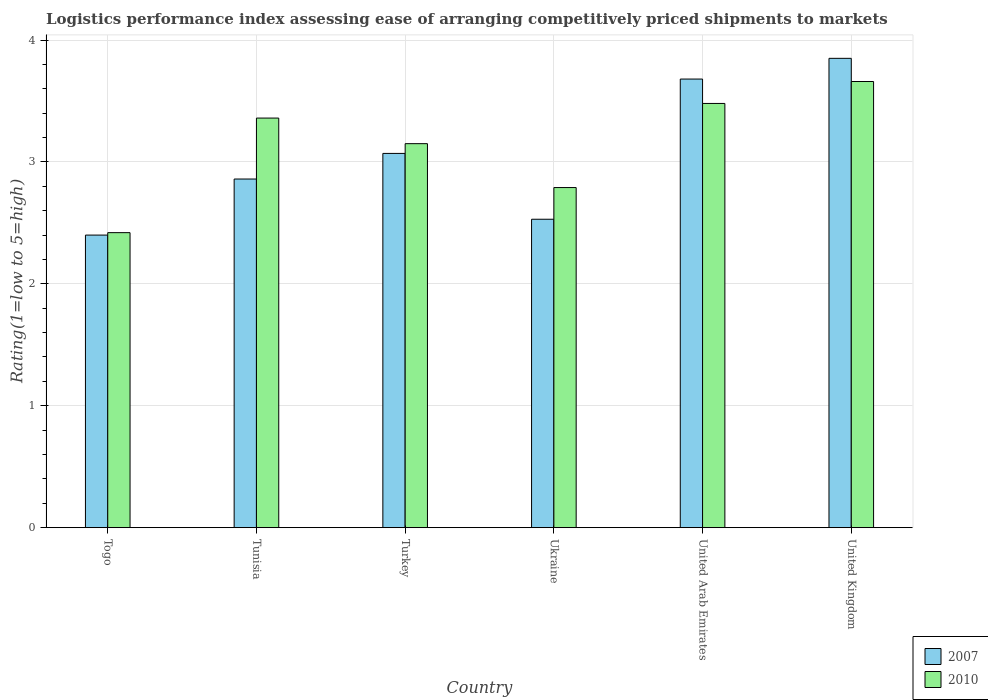How many groups of bars are there?
Offer a very short reply. 6. Are the number of bars on each tick of the X-axis equal?
Make the answer very short. Yes. How many bars are there on the 3rd tick from the left?
Offer a terse response. 2. How many bars are there on the 3rd tick from the right?
Your answer should be very brief. 2. What is the label of the 5th group of bars from the left?
Make the answer very short. United Arab Emirates. In how many cases, is the number of bars for a given country not equal to the number of legend labels?
Offer a terse response. 0. What is the Logistic performance index in 2010 in Tunisia?
Offer a very short reply. 3.36. Across all countries, what is the maximum Logistic performance index in 2007?
Offer a very short reply. 3.85. In which country was the Logistic performance index in 2010 minimum?
Keep it short and to the point. Togo. What is the total Logistic performance index in 2010 in the graph?
Provide a succinct answer. 18.86. What is the difference between the Logistic performance index in 2007 in Tunisia and that in Turkey?
Offer a very short reply. -0.21. What is the difference between the Logistic performance index in 2007 in United Kingdom and the Logistic performance index in 2010 in United Arab Emirates?
Offer a terse response. 0.37. What is the average Logistic performance index in 2010 per country?
Your response must be concise. 3.14. What is the difference between the Logistic performance index of/in 2007 and Logistic performance index of/in 2010 in Tunisia?
Ensure brevity in your answer.  -0.5. In how many countries, is the Logistic performance index in 2007 greater than 0.6000000000000001?
Your answer should be very brief. 6. What is the ratio of the Logistic performance index in 2010 in Turkey to that in United Kingdom?
Keep it short and to the point. 0.86. Is the difference between the Logistic performance index in 2007 in Togo and Tunisia greater than the difference between the Logistic performance index in 2010 in Togo and Tunisia?
Make the answer very short. Yes. What is the difference between the highest and the second highest Logistic performance index in 2007?
Your answer should be compact. -0.17. What is the difference between the highest and the lowest Logistic performance index in 2010?
Provide a short and direct response. 1.24. Is the sum of the Logistic performance index in 2010 in Tunisia and United Kingdom greater than the maximum Logistic performance index in 2007 across all countries?
Provide a short and direct response. Yes. What does the 1st bar from the left in Tunisia represents?
Give a very brief answer. 2007. What is the difference between two consecutive major ticks on the Y-axis?
Your response must be concise. 1. Are the values on the major ticks of Y-axis written in scientific E-notation?
Offer a very short reply. No. Does the graph contain grids?
Offer a terse response. Yes. Where does the legend appear in the graph?
Ensure brevity in your answer.  Bottom right. How many legend labels are there?
Make the answer very short. 2. What is the title of the graph?
Provide a succinct answer. Logistics performance index assessing ease of arranging competitively priced shipments to markets. Does "1994" appear as one of the legend labels in the graph?
Your answer should be very brief. No. What is the label or title of the X-axis?
Give a very brief answer. Country. What is the label or title of the Y-axis?
Give a very brief answer. Rating(1=low to 5=high). What is the Rating(1=low to 5=high) of 2007 in Togo?
Make the answer very short. 2.4. What is the Rating(1=low to 5=high) in 2010 in Togo?
Your response must be concise. 2.42. What is the Rating(1=low to 5=high) in 2007 in Tunisia?
Provide a short and direct response. 2.86. What is the Rating(1=low to 5=high) in 2010 in Tunisia?
Provide a short and direct response. 3.36. What is the Rating(1=low to 5=high) in 2007 in Turkey?
Provide a succinct answer. 3.07. What is the Rating(1=low to 5=high) in 2010 in Turkey?
Offer a very short reply. 3.15. What is the Rating(1=low to 5=high) of 2007 in Ukraine?
Your answer should be very brief. 2.53. What is the Rating(1=low to 5=high) of 2010 in Ukraine?
Keep it short and to the point. 2.79. What is the Rating(1=low to 5=high) in 2007 in United Arab Emirates?
Offer a terse response. 3.68. What is the Rating(1=low to 5=high) of 2010 in United Arab Emirates?
Provide a succinct answer. 3.48. What is the Rating(1=low to 5=high) of 2007 in United Kingdom?
Your answer should be compact. 3.85. What is the Rating(1=low to 5=high) in 2010 in United Kingdom?
Your response must be concise. 3.66. Across all countries, what is the maximum Rating(1=low to 5=high) of 2007?
Provide a short and direct response. 3.85. Across all countries, what is the maximum Rating(1=low to 5=high) in 2010?
Make the answer very short. 3.66. Across all countries, what is the minimum Rating(1=low to 5=high) of 2007?
Your answer should be compact. 2.4. Across all countries, what is the minimum Rating(1=low to 5=high) of 2010?
Make the answer very short. 2.42. What is the total Rating(1=low to 5=high) in 2007 in the graph?
Your response must be concise. 18.39. What is the total Rating(1=low to 5=high) in 2010 in the graph?
Provide a short and direct response. 18.86. What is the difference between the Rating(1=low to 5=high) of 2007 in Togo and that in Tunisia?
Give a very brief answer. -0.46. What is the difference between the Rating(1=low to 5=high) of 2010 in Togo and that in Tunisia?
Give a very brief answer. -0.94. What is the difference between the Rating(1=low to 5=high) of 2007 in Togo and that in Turkey?
Make the answer very short. -0.67. What is the difference between the Rating(1=low to 5=high) of 2010 in Togo and that in Turkey?
Your response must be concise. -0.73. What is the difference between the Rating(1=low to 5=high) in 2007 in Togo and that in Ukraine?
Give a very brief answer. -0.13. What is the difference between the Rating(1=low to 5=high) in 2010 in Togo and that in Ukraine?
Provide a short and direct response. -0.37. What is the difference between the Rating(1=low to 5=high) of 2007 in Togo and that in United Arab Emirates?
Offer a terse response. -1.28. What is the difference between the Rating(1=low to 5=high) in 2010 in Togo and that in United Arab Emirates?
Offer a very short reply. -1.06. What is the difference between the Rating(1=low to 5=high) of 2007 in Togo and that in United Kingdom?
Your response must be concise. -1.45. What is the difference between the Rating(1=low to 5=high) of 2010 in Togo and that in United Kingdom?
Keep it short and to the point. -1.24. What is the difference between the Rating(1=low to 5=high) of 2007 in Tunisia and that in Turkey?
Make the answer very short. -0.21. What is the difference between the Rating(1=low to 5=high) of 2010 in Tunisia and that in Turkey?
Your answer should be compact. 0.21. What is the difference between the Rating(1=low to 5=high) of 2007 in Tunisia and that in Ukraine?
Your answer should be very brief. 0.33. What is the difference between the Rating(1=low to 5=high) of 2010 in Tunisia and that in Ukraine?
Your response must be concise. 0.57. What is the difference between the Rating(1=low to 5=high) in 2007 in Tunisia and that in United Arab Emirates?
Offer a very short reply. -0.82. What is the difference between the Rating(1=low to 5=high) in 2010 in Tunisia and that in United Arab Emirates?
Offer a terse response. -0.12. What is the difference between the Rating(1=low to 5=high) in 2007 in Tunisia and that in United Kingdom?
Provide a succinct answer. -0.99. What is the difference between the Rating(1=low to 5=high) in 2010 in Tunisia and that in United Kingdom?
Provide a short and direct response. -0.3. What is the difference between the Rating(1=low to 5=high) of 2007 in Turkey and that in Ukraine?
Make the answer very short. 0.54. What is the difference between the Rating(1=low to 5=high) of 2010 in Turkey and that in Ukraine?
Your answer should be very brief. 0.36. What is the difference between the Rating(1=low to 5=high) of 2007 in Turkey and that in United Arab Emirates?
Provide a short and direct response. -0.61. What is the difference between the Rating(1=low to 5=high) of 2010 in Turkey and that in United Arab Emirates?
Make the answer very short. -0.33. What is the difference between the Rating(1=low to 5=high) of 2007 in Turkey and that in United Kingdom?
Offer a terse response. -0.78. What is the difference between the Rating(1=low to 5=high) in 2010 in Turkey and that in United Kingdom?
Offer a terse response. -0.51. What is the difference between the Rating(1=low to 5=high) of 2007 in Ukraine and that in United Arab Emirates?
Offer a terse response. -1.15. What is the difference between the Rating(1=low to 5=high) in 2010 in Ukraine and that in United Arab Emirates?
Keep it short and to the point. -0.69. What is the difference between the Rating(1=low to 5=high) in 2007 in Ukraine and that in United Kingdom?
Offer a terse response. -1.32. What is the difference between the Rating(1=low to 5=high) in 2010 in Ukraine and that in United Kingdom?
Offer a very short reply. -0.87. What is the difference between the Rating(1=low to 5=high) in 2007 in United Arab Emirates and that in United Kingdom?
Your response must be concise. -0.17. What is the difference between the Rating(1=low to 5=high) of 2010 in United Arab Emirates and that in United Kingdom?
Offer a terse response. -0.18. What is the difference between the Rating(1=low to 5=high) in 2007 in Togo and the Rating(1=low to 5=high) in 2010 in Tunisia?
Your answer should be very brief. -0.96. What is the difference between the Rating(1=low to 5=high) of 2007 in Togo and the Rating(1=low to 5=high) of 2010 in Turkey?
Keep it short and to the point. -0.75. What is the difference between the Rating(1=low to 5=high) in 2007 in Togo and the Rating(1=low to 5=high) in 2010 in Ukraine?
Provide a succinct answer. -0.39. What is the difference between the Rating(1=low to 5=high) of 2007 in Togo and the Rating(1=low to 5=high) of 2010 in United Arab Emirates?
Offer a terse response. -1.08. What is the difference between the Rating(1=low to 5=high) of 2007 in Togo and the Rating(1=low to 5=high) of 2010 in United Kingdom?
Your answer should be very brief. -1.26. What is the difference between the Rating(1=low to 5=high) of 2007 in Tunisia and the Rating(1=low to 5=high) of 2010 in Turkey?
Make the answer very short. -0.29. What is the difference between the Rating(1=low to 5=high) of 2007 in Tunisia and the Rating(1=low to 5=high) of 2010 in Ukraine?
Provide a short and direct response. 0.07. What is the difference between the Rating(1=low to 5=high) in 2007 in Tunisia and the Rating(1=low to 5=high) in 2010 in United Arab Emirates?
Ensure brevity in your answer.  -0.62. What is the difference between the Rating(1=low to 5=high) of 2007 in Tunisia and the Rating(1=low to 5=high) of 2010 in United Kingdom?
Ensure brevity in your answer.  -0.8. What is the difference between the Rating(1=low to 5=high) in 2007 in Turkey and the Rating(1=low to 5=high) in 2010 in Ukraine?
Provide a short and direct response. 0.28. What is the difference between the Rating(1=low to 5=high) in 2007 in Turkey and the Rating(1=low to 5=high) in 2010 in United Arab Emirates?
Provide a short and direct response. -0.41. What is the difference between the Rating(1=low to 5=high) in 2007 in Turkey and the Rating(1=low to 5=high) in 2010 in United Kingdom?
Keep it short and to the point. -0.59. What is the difference between the Rating(1=low to 5=high) of 2007 in Ukraine and the Rating(1=low to 5=high) of 2010 in United Arab Emirates?
Provide a short and direct response. -0.95. What is the difference between the Rating(1=low to 5=high) of 2007 in Ukraine and the Rating(1=low to 5=high) of 2010 in United Kingdom?
Keep it short and to the point. -1.13. What is the difference between the Rating(1=low to 5=high) in 2007 in United Arab Emirates and the Rating(1=low to 5=high) in 2010 in United Kingdom?
Provide a succinct answer. 0.02. What is the average Rating(1=low to 5=high) of 2007 per country?
Offer a very short reply. 3.06. What is the average Rating(1=low to 5=high) in 2010 per country?
Your response must be concise. 3.14. What is the difference between the Rating(1=low to 5=high) of 2007 and Rating(1=low to 5=high) of 2010 in Togo?
Ensure brevity in your answer.  -0.02. What is the difference between the Rating(1=low to 5=high) of 2007 and Rating(1=low to 5=high) of 2010 in Tunisia?
Provide a short and direct response. -0.5. What is the difference between the Rating(1=low to 5=high) in 2007 and Rating(1=low to 5=high) in 2010 in Turkey?
Ensure brevity in your answer.  -0.08. What is the difference between the Rating(1=low to 5=high) of 2007 and Rating(1=low to 5=high) of 2010 in Ukraine?
Make the answer very short. -0.26. What is the difference between the Rating(1=low to 5=high) of 2007 and Rating(1=low to 5=high) of 2010 in United Kingdom?
Provide a short and direct response. 0.19. What is the ratio of the Rating(1=low to 5=high) of 2007 in Togo to that in Tunisia?
Provide a short and direct response. 0.84. What is the ratio of the Rating(1=low to 5=high) in 2010 in Togo to that in Tunisia?
Make the answer very short. 0.72. What is the ratio of the Rating(1=low to 5=high) in 2007 in Togo to that in Turkey?
Your answer should be very brief. 0.78. What is the ratio of the Rating(1=low to 5=high) of 2010 in Togo to that in Turkey?
Make the answer very short. 0.77. What is the ratio of the Rating(1=low to 5=high) of 2007 in Togo to that in Ukraine?
Ensure brevity in your answer.  0.95. What is the ratio of the Rating(1=low to 5=high) in 2010 in Togo to that in Ukraine?
Keep it short and to the point. 0.87. What is the ratio of the Rating(1=low to 5=high) of 2007 in Togo to that in United Arab Emirates?
Provide a short and direct response. 0.65. What is the ratio of the Rating(1=low to 5=high) of 2010 in Togo to that in United Arab Emirates?
Give a very brief answer. 0.7. What is the ratio of the Rating(1=low to 5=high) of 2007 in Togo to that in United Kingdom?
Your answer should be compact. 0.62. What is the ratio of the Rating(1=low to 5=high) of 2010 in Togo to that in United Kingdom?
Offer a very short reply. 0.66. What is the ratio of the Rating(1=low to 5=high) of 2007 in Tunisia to that in Turkey?
Your response must be concise. 0.93. What is the ratio of the Rating(1=low to 5=high) in 2010 in Tunisia to that in Turkey?
Make the answer very short. 1.07. What is the ratio of the Rating(1=low to 5=high) of 2007 in Tunisia to that in Ukraine?
Ensure brevity in your answer.  1.13. What is the ratio of the Rating(1=low to 5=high) in 2010 in Tunisia to that in Ukraine?
Provide a short and direct response. 1.2. What is the ratio of the Rating(1=low to 5=high) of 2007 in Tunisia to that in United Arab Emirates?
Ensure brevity in your answer.  0.78. What is the ratio of the Rating(1=low to 5=high) of 2010 in Tunisia to that in United Arab Emirates?
Ensure brevity in your answer.  0.97. What is the ratio of the Rating(1=low to 5=high) of 2007 in Tunisia to that in United Kingdom?
Give a very brief answer. 0.74. What is the ratio of the Rating(1=low to 5=high) of 2010 in Tunisia to that in United Kingdom?
Your answer should be compact. 0.92. What is the ratio of the Rating(1=low to 5=high) in 2007 in Turkey to that in Ukraine?
Ensure brevity in your answer.  1.21. What is the ratio of the Rating(1=low to 5=high) in 2010 in Turkey to that in Ukraine?
Your answer should be very brief. 1.13. What is the ratio of the Rating(1=low to 5=high) in 2007 in Turkey to that in United Arab Emirates?
Keep it short and to the point. 0.83. What is the ratio of the Rating(1=low to 5=high) in 2010 in Turkey to that in United Arab Emirates?
Your answer should be compact. 0.91. What is the ratio of the Rating(1=low to 5=high) of 2007 in Turkey to that in United Kingdom?
Give a very brief answer. 0.8. What is the ratio of the Rating(1=low to 5=high) of 2010 in Turkey to that in United Kingdom?
Offer a terse response. 0.86. What is the ratio of the Rating(1=low to 5=high) in 2007 in Ukraine to that in United Arab Emirates?
Provide a succinct answer. 0.69. What is the ratio of the Rating(1=low to 5=high) in 2010 in Ukraine to that in United Arab Emirates?
Your answer should be very brief. 0.8. What is the ratio of the Rating(1=low to 5=high) in 2007 in Ukraine to that in United Kingdom?
Make the answer very short. 0.66. What is the ratio of the Rating(1=low to 5=high) in 2010 in Ukraine to that in United Kingdom?
Offer a very short reply. 0.76. What is the ratio of the Rating(1=low to 5=high) in 2007 in United Arab Emirates to that in United Kingdom?
Your response must be concise. 0.96. What is the ratio of the Rating(1=low to 5=high) in 2010 in United Arab Emirates to that in United Kingdom?
Keep it short and to the point. 0.95. What is the difference between the highest and the second highest Rating(1=low to 5=high) in 2007?
Provide a succinct answer. 0.17. What is the difference between the highest and the second highest Rating(1=low to 5=high) of 2010?
Offer a very short reply. 0.18. What is the difference between the highest and the lowest Rating(1=low to 5=high) in 2007?
Your answer should be compact. 1.45. What is the difference between the highest and the lowest Rating(1=low to 5=high) in 2010?
Make the answer very short. 1.24. 